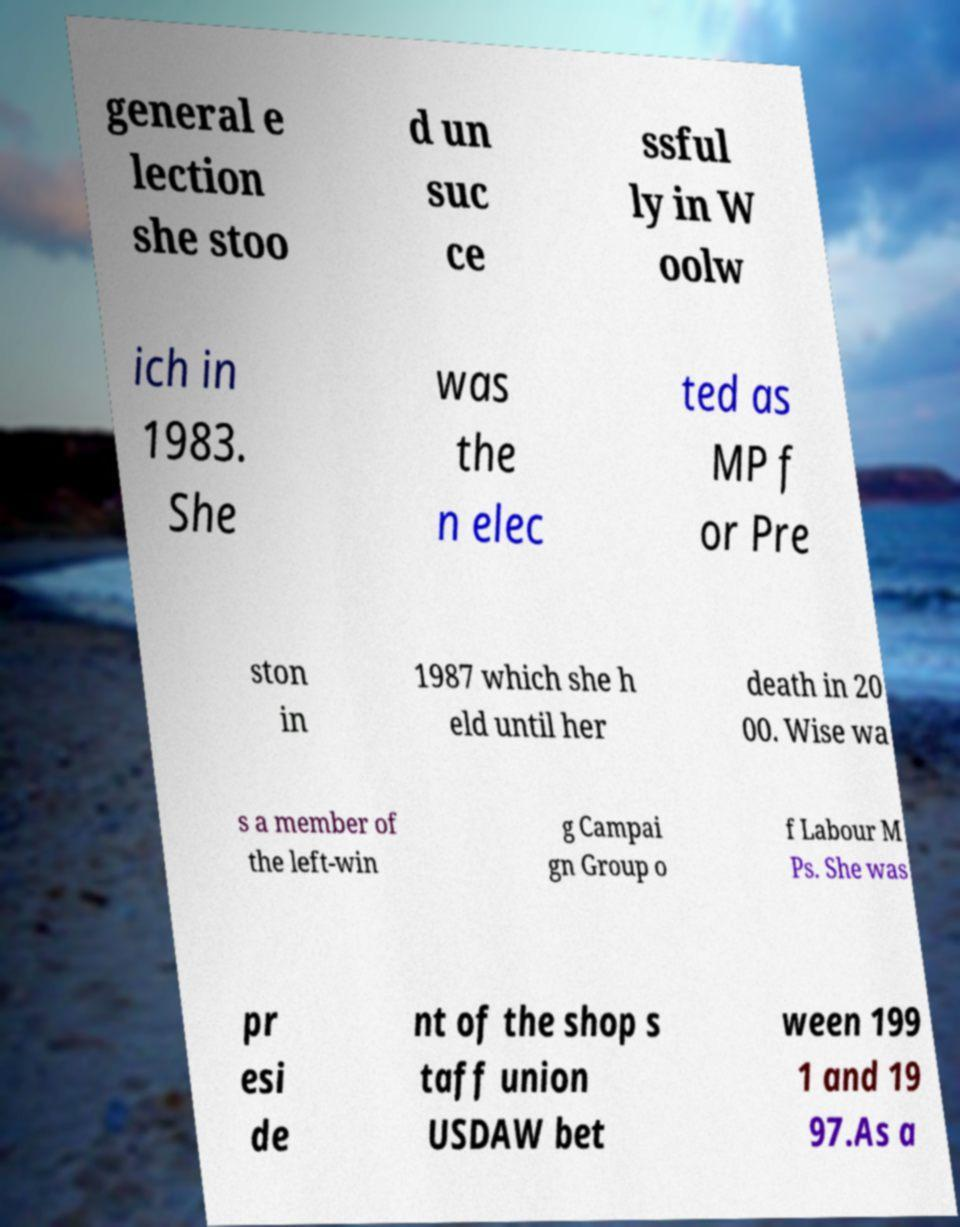Can you read and provide the text displayed in the image?This photo seems to have some interesting text. Can you extract and type it out for me? general e lection she stoo d un suc ce ssful ly in W oolw ich in 1983. She was the n elec ted as MP f or Pre ston in 1987 which she h eld until her death in 20 00. Wise wa s a member of the left-win g Campai gn Group o f Labour M Ps. She was pr esi de nt of the shop s taff union USDAW bet ween 199 1 and 19 97.As a 